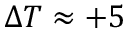Convert formula to latex. <formula><loc_0><loc_0><loc_500><loc_500>\Delta T \approx + 5</formula> 